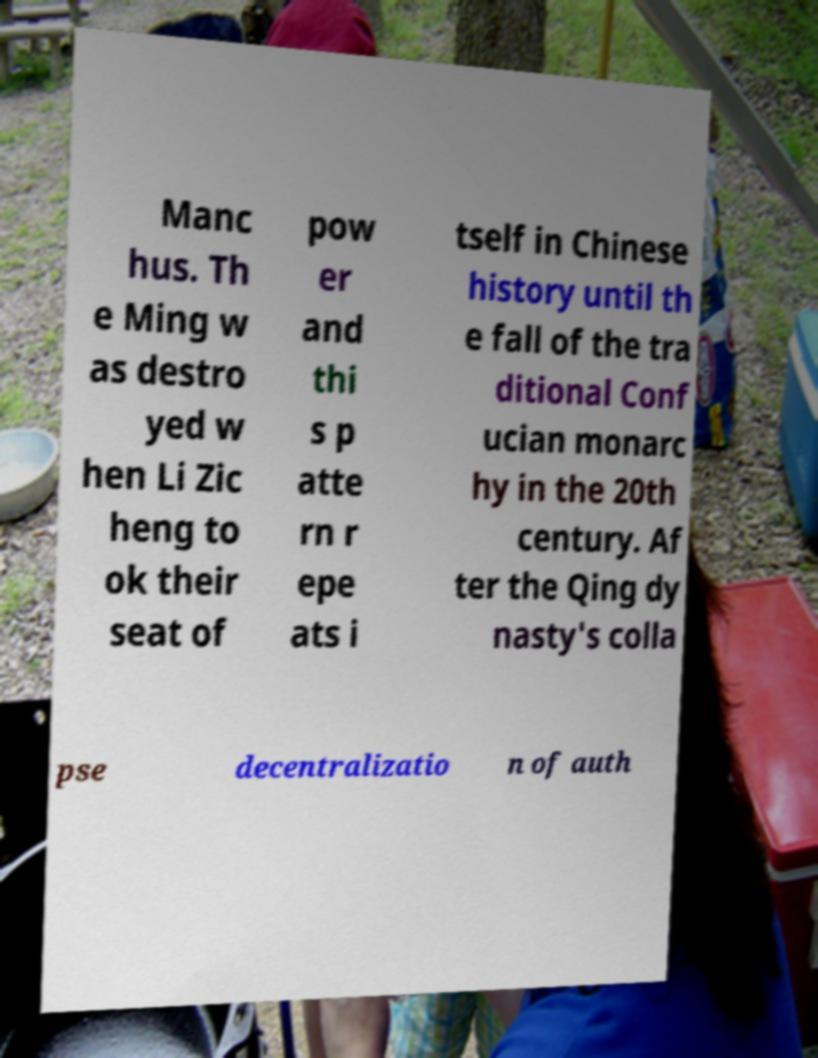I need the written content from this picture converted into text. Can you do that? Manc hus. Th e Ming w as destro yed w hen Li Zic heng to ok their seat of pow er and thi s p atte rn r epe ats i tself in Chinese history until th e fall of the tra ditional Conf ucian monarc hy in the 20th century. Af ter the Qing dy nasty's colla pse decentralizatio n of auth 